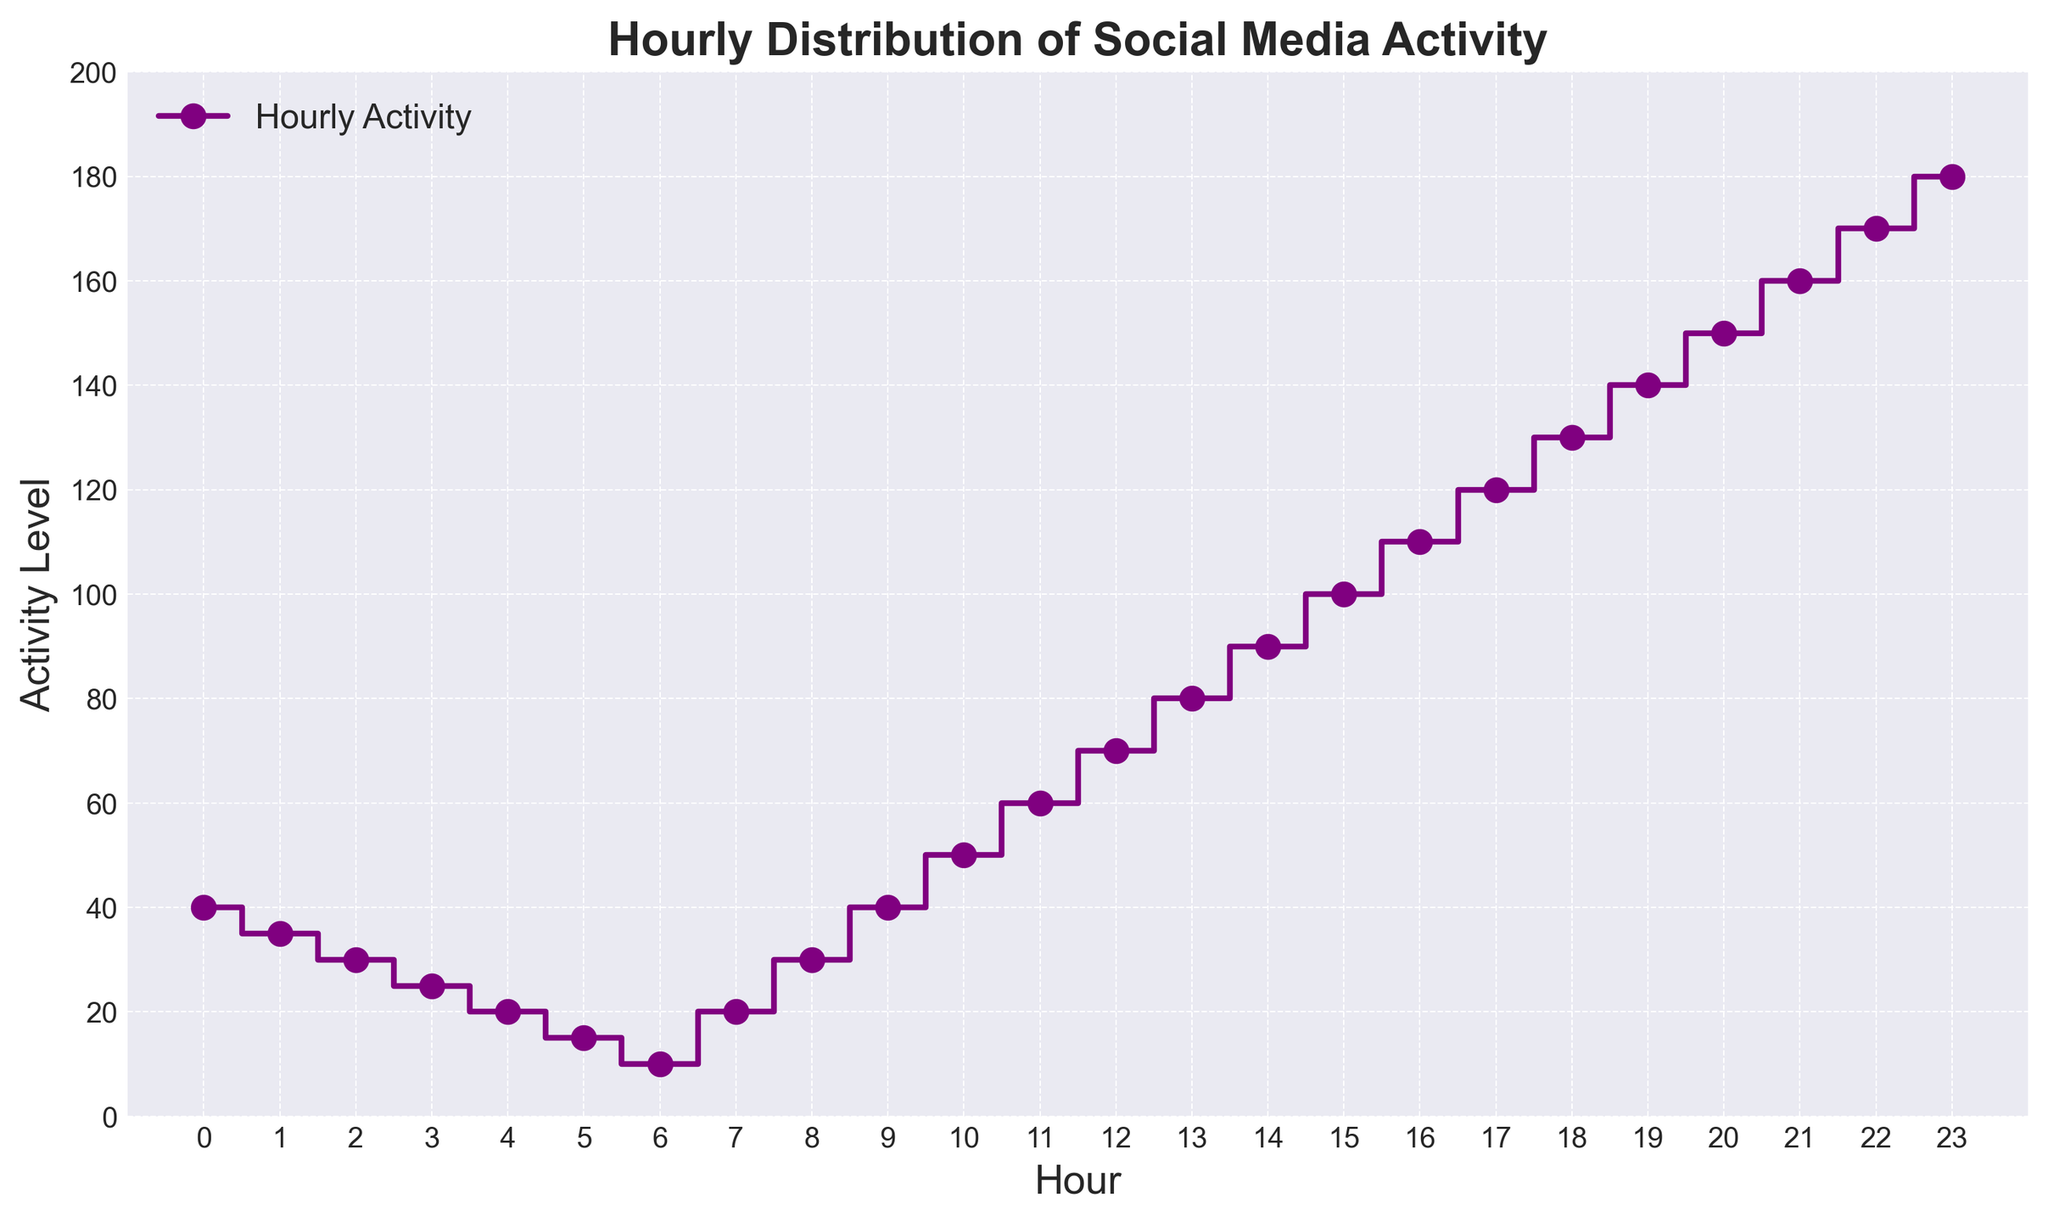Which hour shows the highest level of social media activity? The highest data point in the figure corresponds to the highest social media activity. The data point at hour 23 has the highest activity level.
Answer: 23 At what hour does the social media activity reach 100? By observing the stair-step plot, the activity level of 100 is reached at hour 15.
Answer: 15 How does the social media activity level at 9 am compare to 9 pm? At 9 am, the activity level is 40, whereas at 9 pm (21:00), the activity level is 160. 160 is greater than 40.
Answer: 9 pm is higher During which hours does the social media activity increase most rapidly? The figure shows a sharp rise in activity between 18:00 and 23:00. Looking at the gradient, the most rapid increase occurs during this period.
Answer: 18:00 to 23:00 What is the average social media activity level between 13:00 and 16:00? The activity levels between 13:00 and 16:00 are 80, 90, 100, 110. Summing these values, (80+90+100+110) gives 380, and averaging, 380/4, we get 95.
Answer: 95 Which two consecutive hours show the largest increase in activity? By observing the step increments, the largest jump is between hours 22:00 and 23:00, where the activity increases from 170 to 180.
Answer: 22:00 and 23:00 At what hour does the daytime (8:00 to 17:00) social media activity plateau the highest? Between 8:00 and 17:00, the highest plateau is 120, which occurs at 17:00.
Answer: 17:00 What is the total social media activity level from 16:00 to 20:00? The activity levels from 16:00 to 20:00 are 110, 120, 130, 140, and 150. Summing these values gives (110 + 120 + 130 + 140 + 150) = 650.
Answer: 650 By how much does social media activity decrease from 0:00 to 5:00? At 0:00, the activity is 40 and at 5:00, it's 15. The decrease is 40 - 15 = 25.
Answer: 25 What is the visual color used to depict the graph? The graph is depicted using a purple color as per the plot description.
Answer: Purple 